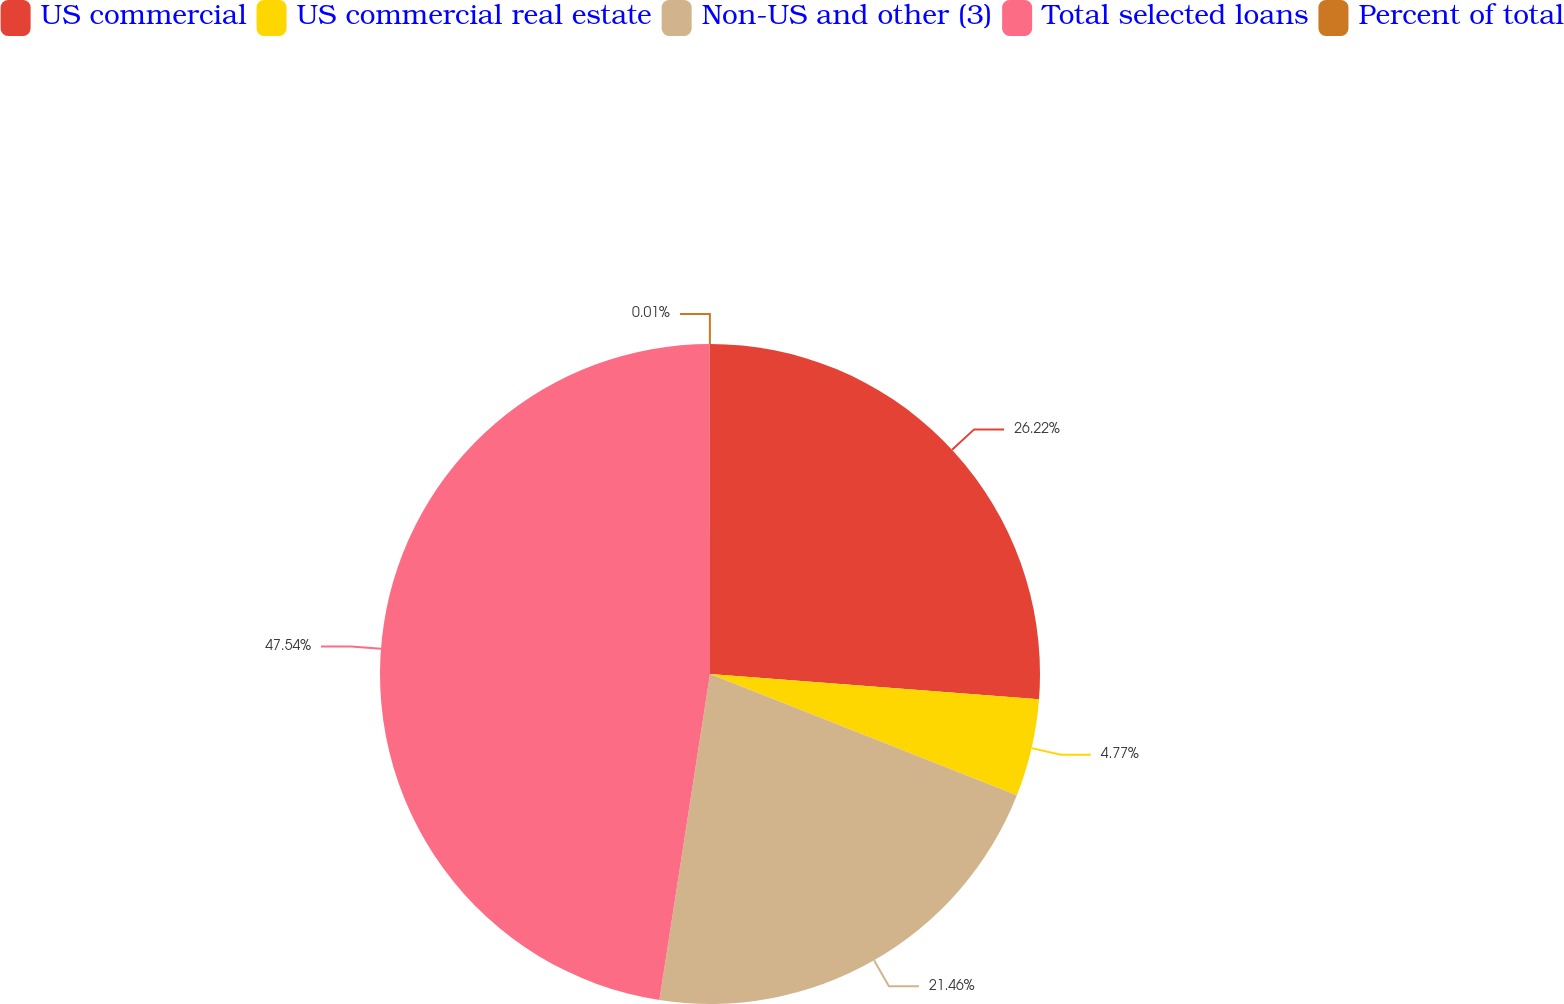Convert chart to OTSL. <chart><loc_0><loc_0><loc_500><loc_500><pie_chart><fcel>US commercial<fcel>US commercial real estate<fcel>Non-US and other (3)<fcel>Total selected loans<fcel>Percent of total<nl><fcel>26.22%<fcel>4.77%<fcel>21.46%<fcel>47.54%<fcel>0.01%<nl></chart> 